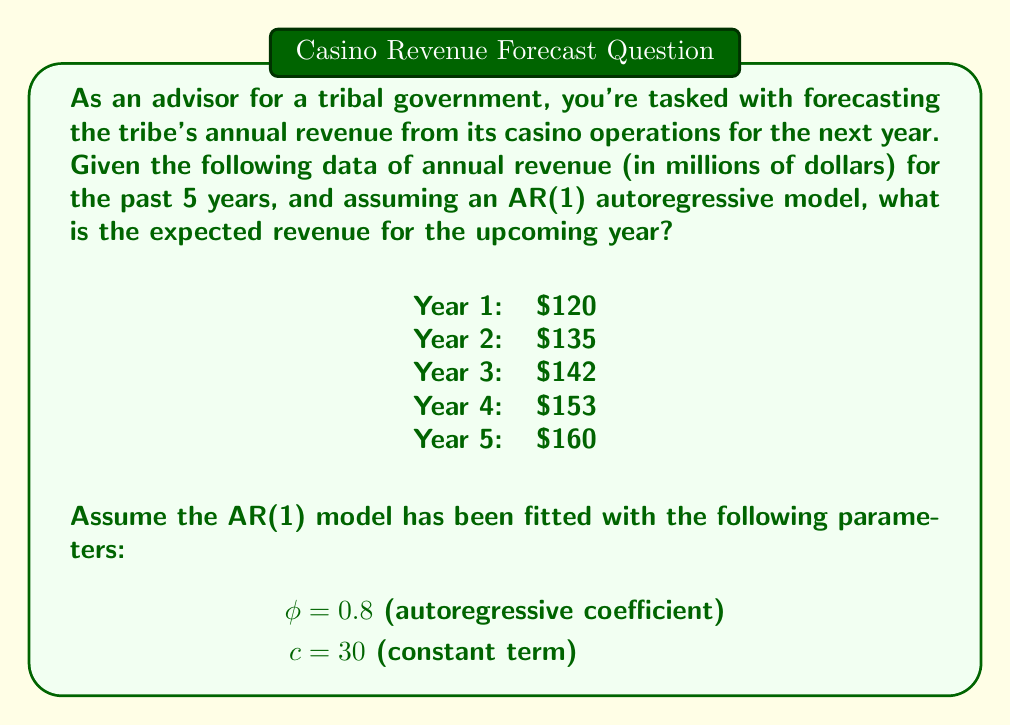Solve this math problem. To forecast the revenue for the upcoming year using an AR(1) (first-order autoregressive) model, we'll follow these steps:

1) The general form of an AR(1) model is:

   $$Y_t = c + \phi Y_{t-1} + \epsilon_t$$

   where $Y_t$ is the value at time $t$, $c$ is a constant, $\phi$ is the autoregressive coefficient, and $\epsilon_t$ is the error term.

2) For forecasting, we ignore the error term $\epsilon_t$, so our forecast equation becomes:

   $$\hat{Y}_t = c + \phi Y_{t-1}$$

3) We're given:
   $c = 30$
   $\phi = 0.8$
   $Y_5 = 160$ (the most recent year's revenue)

4) Let's substitute these values into our forecast equation:

   $$\hat{Y}_6 = 30 + 0.8 \times 160$$

5) Now let's calculate:

   $$\hat{Y}_6 = 30 + 128 = 158$$

Therefore, the expected revenue for the upcoming year (Year 6) is $158 million.

Note: This simple AR(1) model assumes that the revenue in any given year depends only on the revenue from the previous year and a constant term. In practice, more complex models might be used to capture additional factors and longer-term trends.
Answer: $158 million 